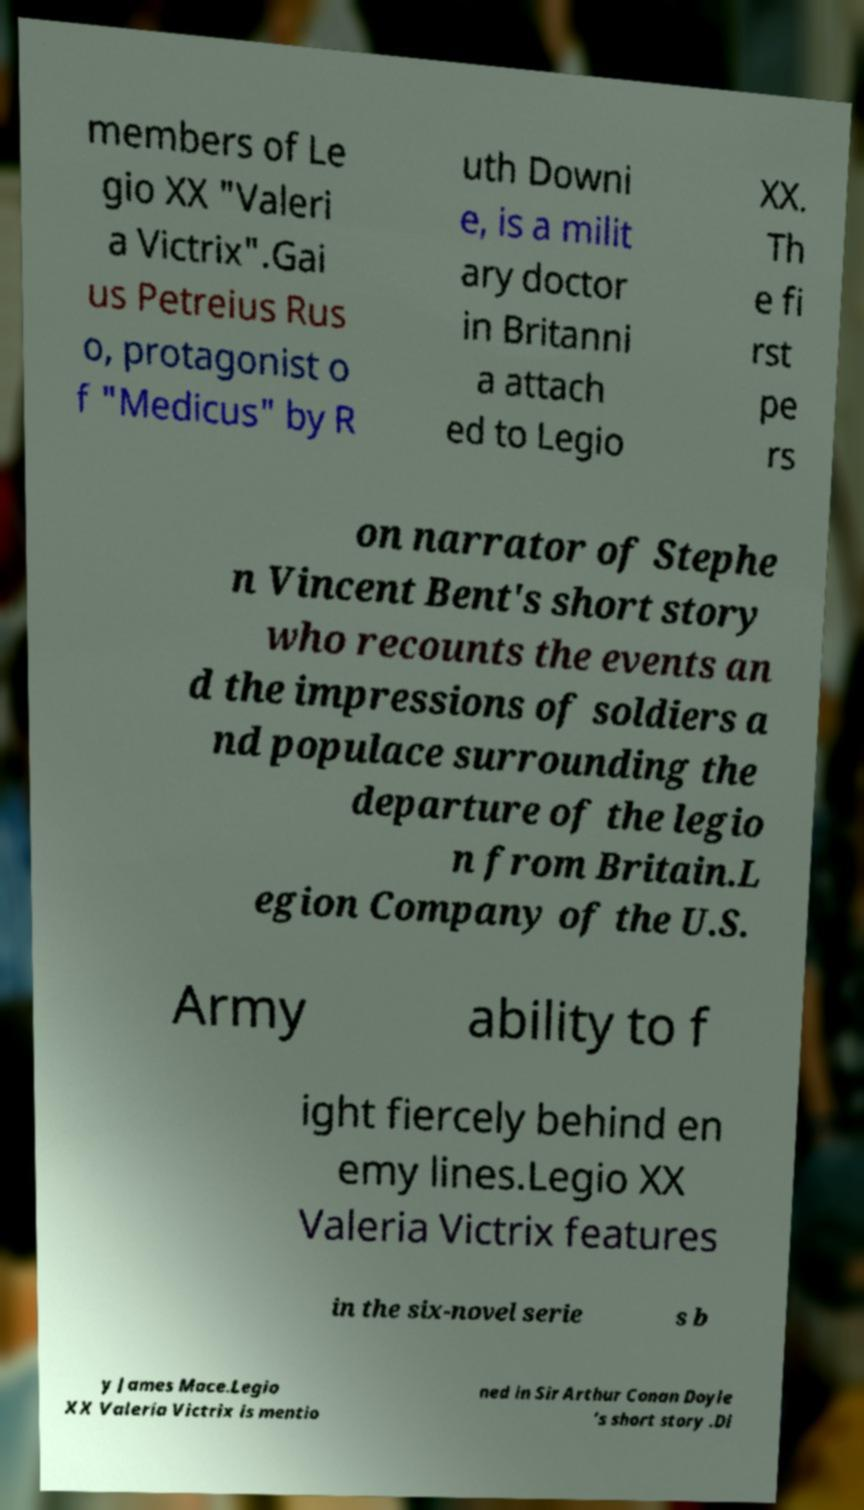Could you assist in decoding the text presented in this image and type it out clearly? members of Le gio XX "Valeri a Victrix".Gai us Petreius Rus o, protagonist o f "Medicus" by R uth Downi e, is a milit ary doctor in Britanni a attach ed to Legio XX. Th e fi rst pe rs on narrator of Stephe n Vincent Bent's short story who recounts the events an d the impressions of soldiers a nd populace surrounding the departure of the legio n from Britain.L egion Company of the U.S. Army ability to f ight fiercely behind en emy lines.Legio XX Valeria Victrix features in the six-novel serie s b y James Mace.Legio XX Valeria Victrix is mentio ned in Sir Arthur Conan Doyle ’s short story .Di 